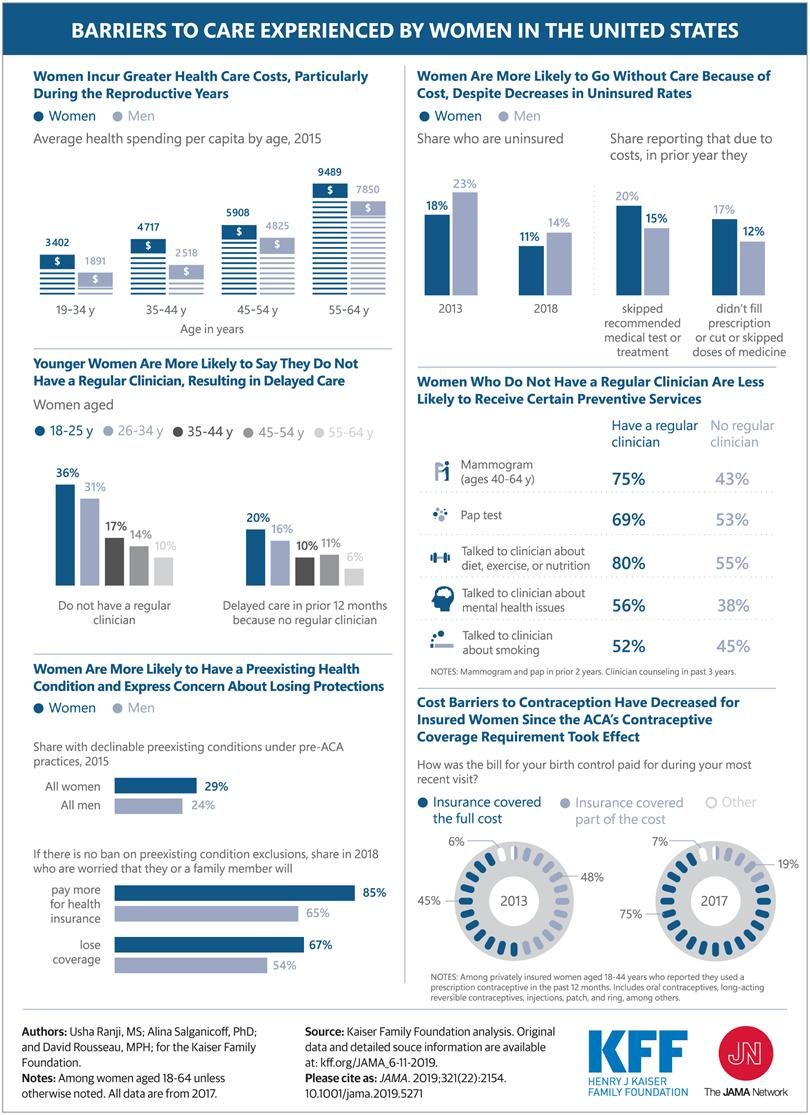List a handful of essential elements in this visual. The percentage of women who were uninsured decreased significantly from 2013 to 2018. The cost of health for young women is significantly higher than that of young men, with a difference of 1,511. According to the data, 31% of 26-34 year old women do not have regular clinicians. According to the data, approximately 14% of 45-54 year old women do not have a regular clinician. The healthcare cost for senior women is 1,639 more than that of men. 